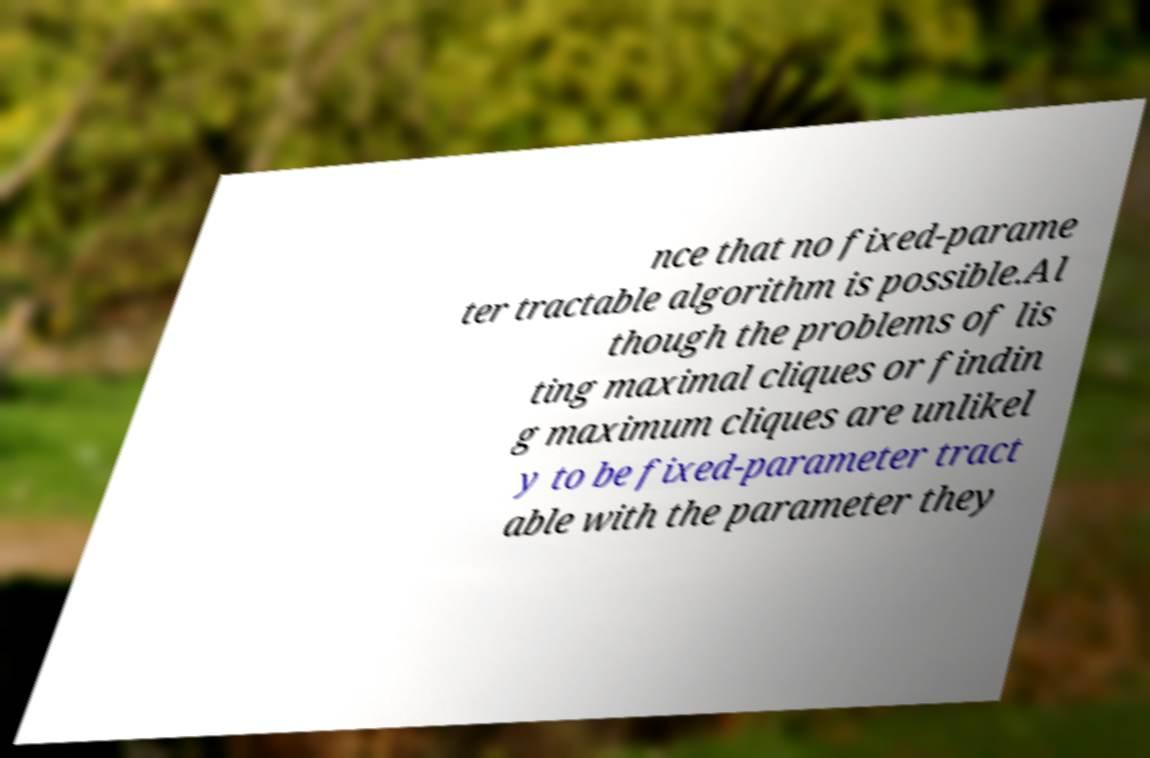Can you read and provide the text displayed in the image?This photo seems to have some interesting text. Can you extract and type it out for me? nce that no fixed-parame ter tractable algorithm is possible.Al though the problems of lis ting maximal cliques or findin g maximum cliques are unlikel y to be fixed-parameter tract able with the parameter they 